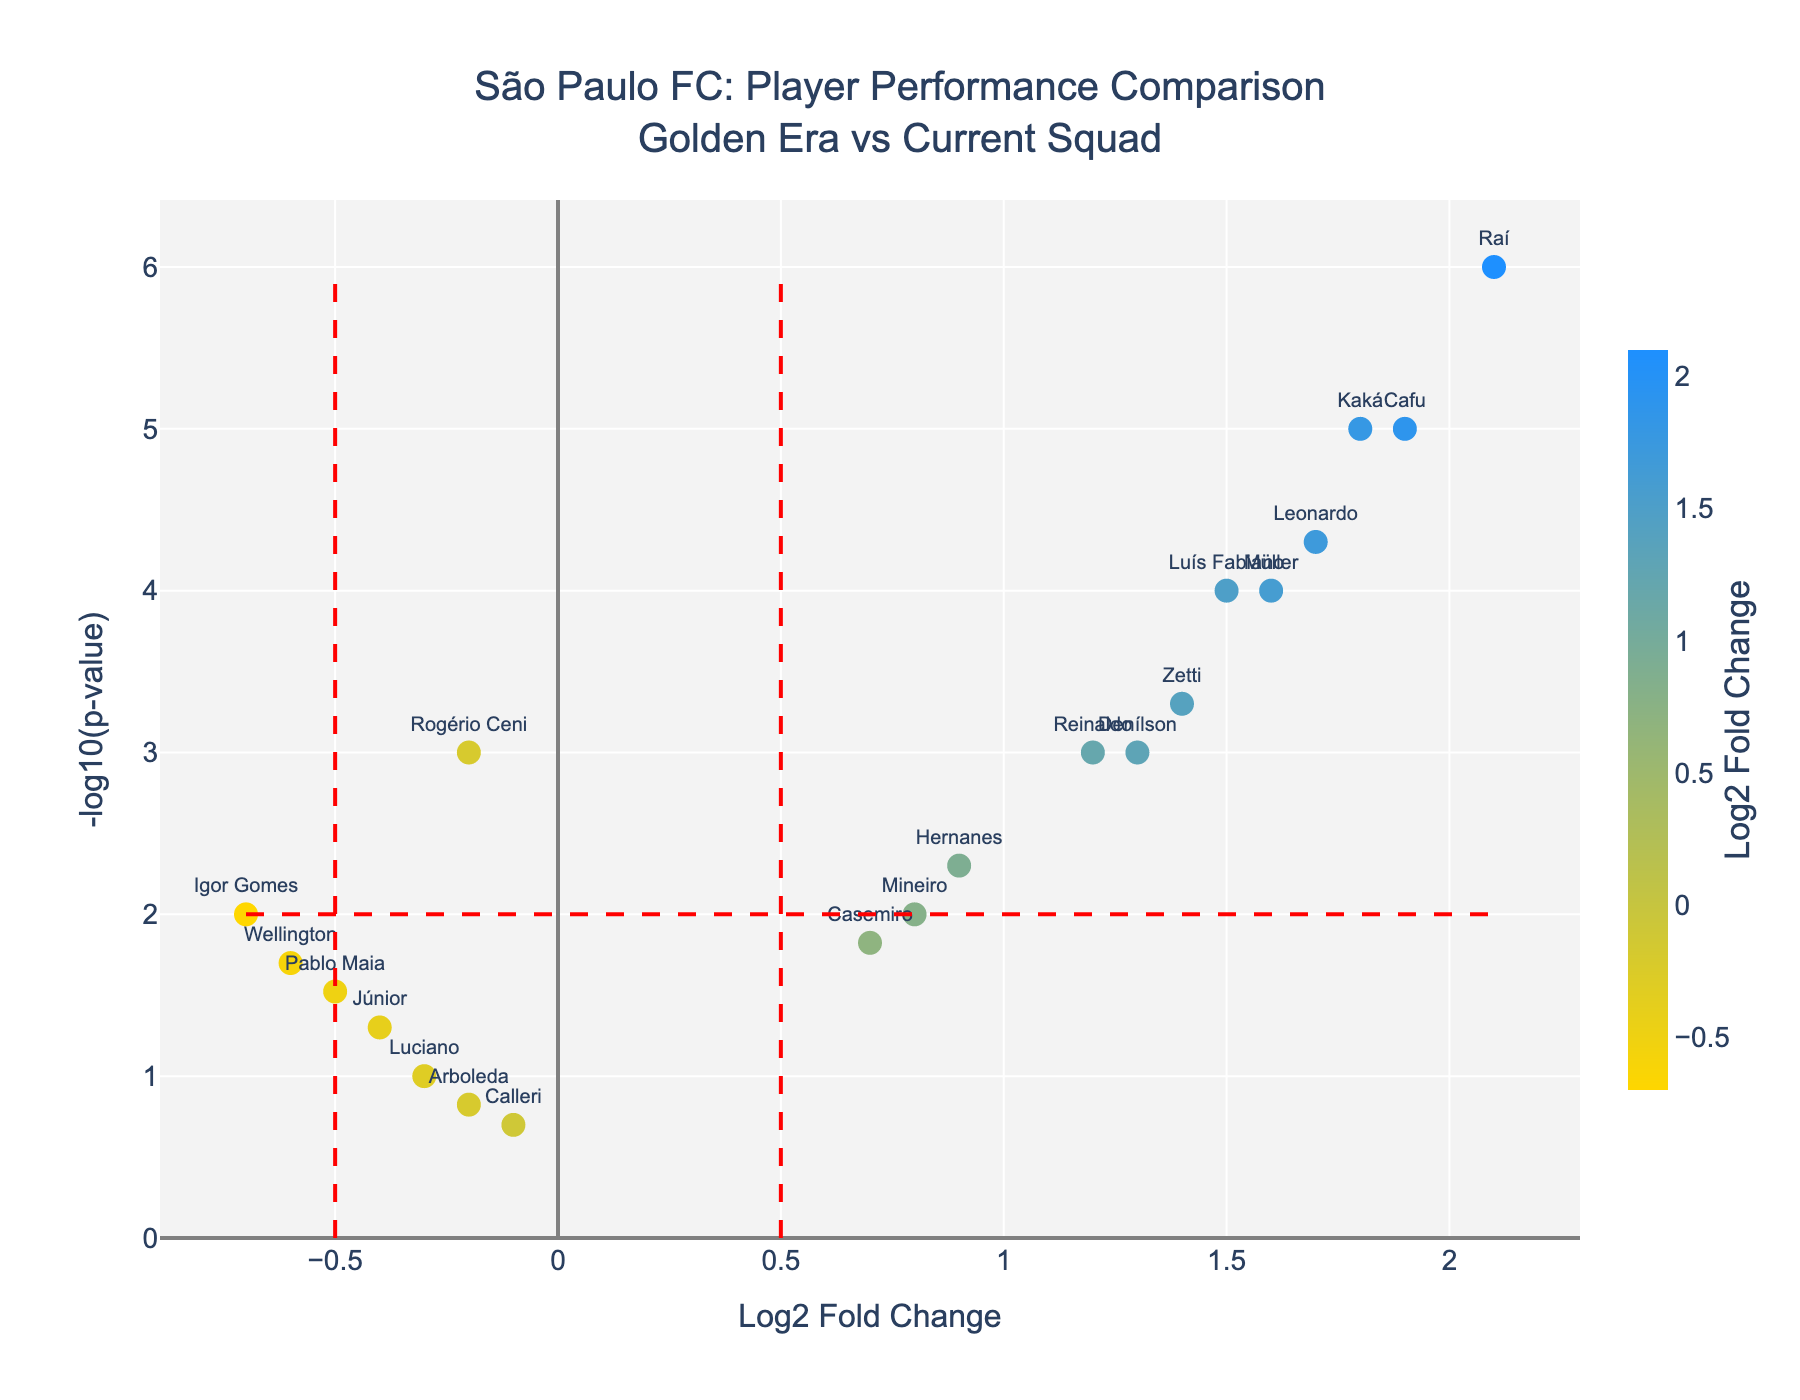How many players from the current squad have fold change values less than zero? There are four players from the current squad with fold change values less than zero: Rogério Ceni, Júnior, Igor Gomes, Pablo Maia, and Wellington.
Answer: 5 Who is the player with the highest LogFoldChange value? Raí has the highest LogFoldChange value of 2.1.
Answer: Raí How many players have a p-value less than 0.01? Players with a p-value less than 0.01 are: Rogério Ceni, Kaká, Luís Fabiano, Raí, Leonardo, Cafu, Reinaldo, and Zetti. There are eight such players.
Answer: 8 Which player from the golden era has a LogFoldChange value closest to 1.5? Luís Fabiano has a LogFoldChange value of 1.5, which is closest to the specified value.
Answer: Luís Fabiano Among the players shown, who has the lowest p-value? Raí has the lowest p-value, which is 0.000001.
Answer: Raí Between Kaká and Müller, who has a higher -log10(p-value)? -log10(p-value) of Kaká is higher. He has a -log10(p-value) of 5, while Müller's -log10(p-value) is 4.
Answer: Kaká Which players have LogFoldChange values greater than 1 and a p-value less than 0.05? The players are Kaká, Luís Fabiano, Raí, Leonardo, Cafu, Müller, Reinaldo, and Denílson.
Answer: Kaká, Luís Fabiano, Raí, Leonardo, Cafu, Müller, Reinaldo, Denílson What is the LogFoldChange value for the goalkeeper from the golden era, Rogério Ceni, and how does it compare to Júnior's value? Rogério Ceni has a LogFoldChange value of -0.2, while Júnior has a value of -0.4.
Answer: Rogério Ceni's value is higher Who among the current squad has the most significant negative LogFoldChange? Igor Gomes has the most significant negative LogFoldChange value of -0.7.
Answer: Igor Gomes What can be inferred about Calleri based on the fold change and p-value represented in the plot? Calleri has a fold change close to zero (indicating little or no change) and a high p-value (non-significant change).
Answer: Little or no change, non-significant 